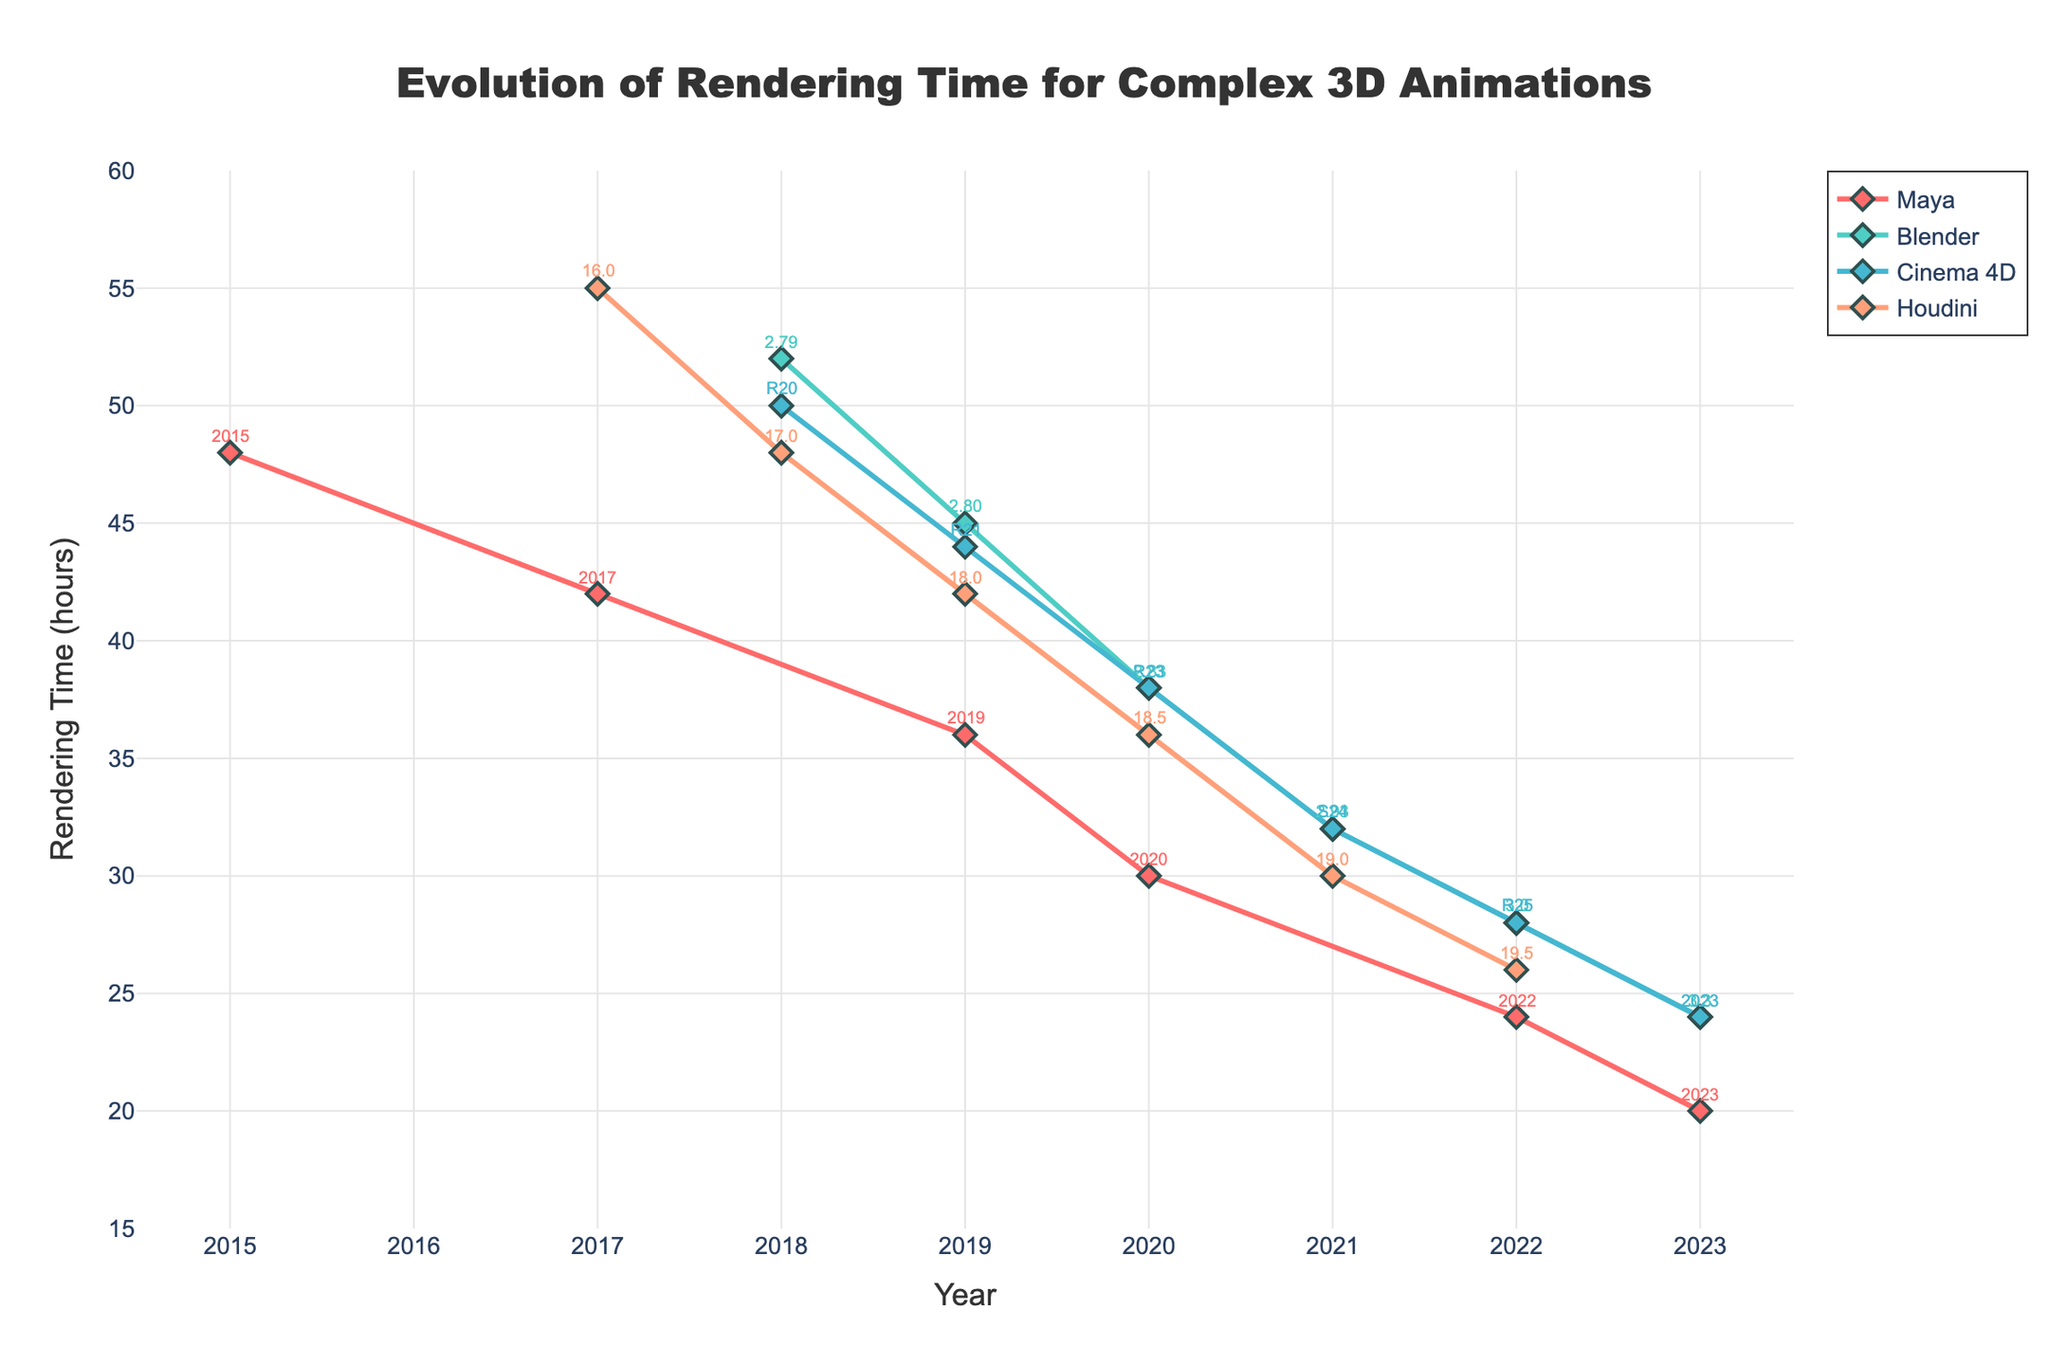Which software had the longest rendering time in 2017? According to the figure, Houdini had the longest rendering time in 2017 with 55 hours.
Answer: Houdini Which software had the shortest rendering time in 2023? In 2023, according to the figure, Maya had the shortest rendering time with 20 hours.
Answer: Maya Calculate the average rendering time for Blender across all years presented. To calculate the average, sum up the rendering times for Blender from 2018 to 2023: (52 + 45 + 38 + 32 + 28 + 24) = 219 hours. Divide this by the number of years (6): 219 / 6 = 36.5 hours.
Answer: 36.5 Between 2019 and 2020, which software had the most significant improvement in rendering time and by how much? By comparing the reduction in rendering time from 2019 to 2020, Maya improved from 36 to 30 hours (6 hours improvement), Blender from 45 to 38 hours (7 hours improvement), Cinema 4D from 44 to 38 hours (6 hours improvement), and Houdini from 42 to 36 hours (6 hours improvement). The most significant improvement was Blender with a 7 hours reduction.
Answer: Blender, 7 hours What is the trend in rendering time for Cinema 4D from 2018 to 2023? The trend for Cinema 4D shows a consistent decrease in rendering time each year: 50 hours in 2018, 44 in 2019, 38 in 2020, 32 in 2021, 28 in 2022, and 24 in 2023.
Answer: Decreasing trend Comparing 2018 with 2023, how much has the rendering time improved for Houdini? Houdini had a rendering time of 48 hours in 2018 and 26 hours in 2022. The improvement is calculated as 48 - 26 = 22 hours.
Answer: 22 hours Did any software have the same rendering time of 24 hours in 2023? By observing 2023, Maya, Blender, and Cinema 4D all had a rendering time of 24 hours.
Answer: Maya, Blender, Cinema 4D Which year shows the fastest decrease in rendering time for Maya? By looking at the year-to-year changes for Maya: from 2015 to 2017 (48 to 42 hours = 6 hours), from 2017 to 2019 (42 to 36 = 6 hours), 2019 to 2020 (36 to 30 hours = 6 hours), 2020 to 2022 (30 to 24 hours = 6 hours), and 2022 to 2023 (24 to 20 hours = 4 hours). The rapid decrease consistently was 6 hours for several intervals, making no single year the fastest exclusively.
Answer: 2015-2017, 2017-2019, 2019-2020, 2020-2022 all the same How do the trends of rendering times of Blender and Cinema 4D compare from 2019 to 2023? From 2019 to 2023, both Blender and Cinema 4D show a decreasing trend in rendering times. Blender's rendering time decreased from 45 to 24 hours, while Cinema 4D's reduced from 44 to 24 hours. Both showed an identical overall trend in rendering time reduction over these years.
Answer: Similar decreasing trend What is the difference in rendering times between Maya and Houdini in 2020? In 2020, Maya had a rendering time of 30 hours while Houdini had 36 hours. The difference is 36 - 30 = 6 hours.
Answer: 6 hours 